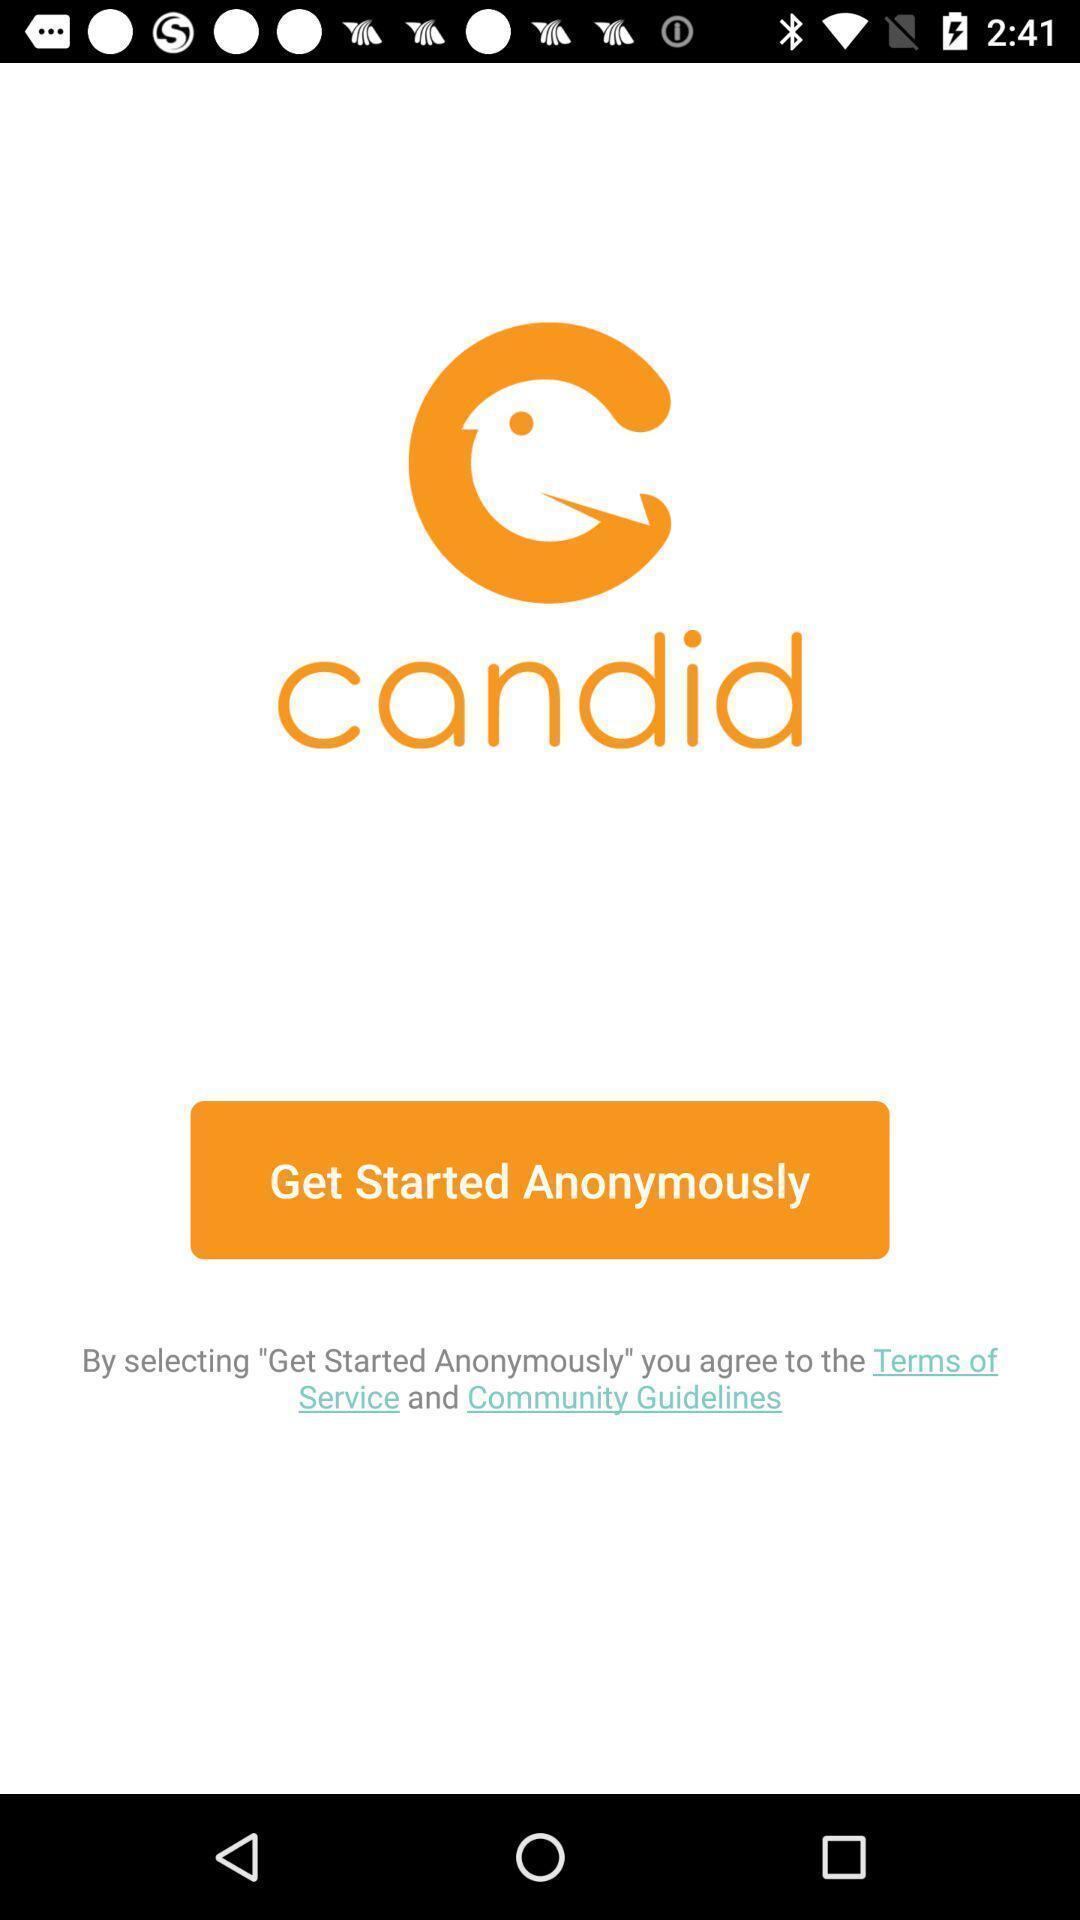What details can you identify in this image? Welcome page showing with start option. 